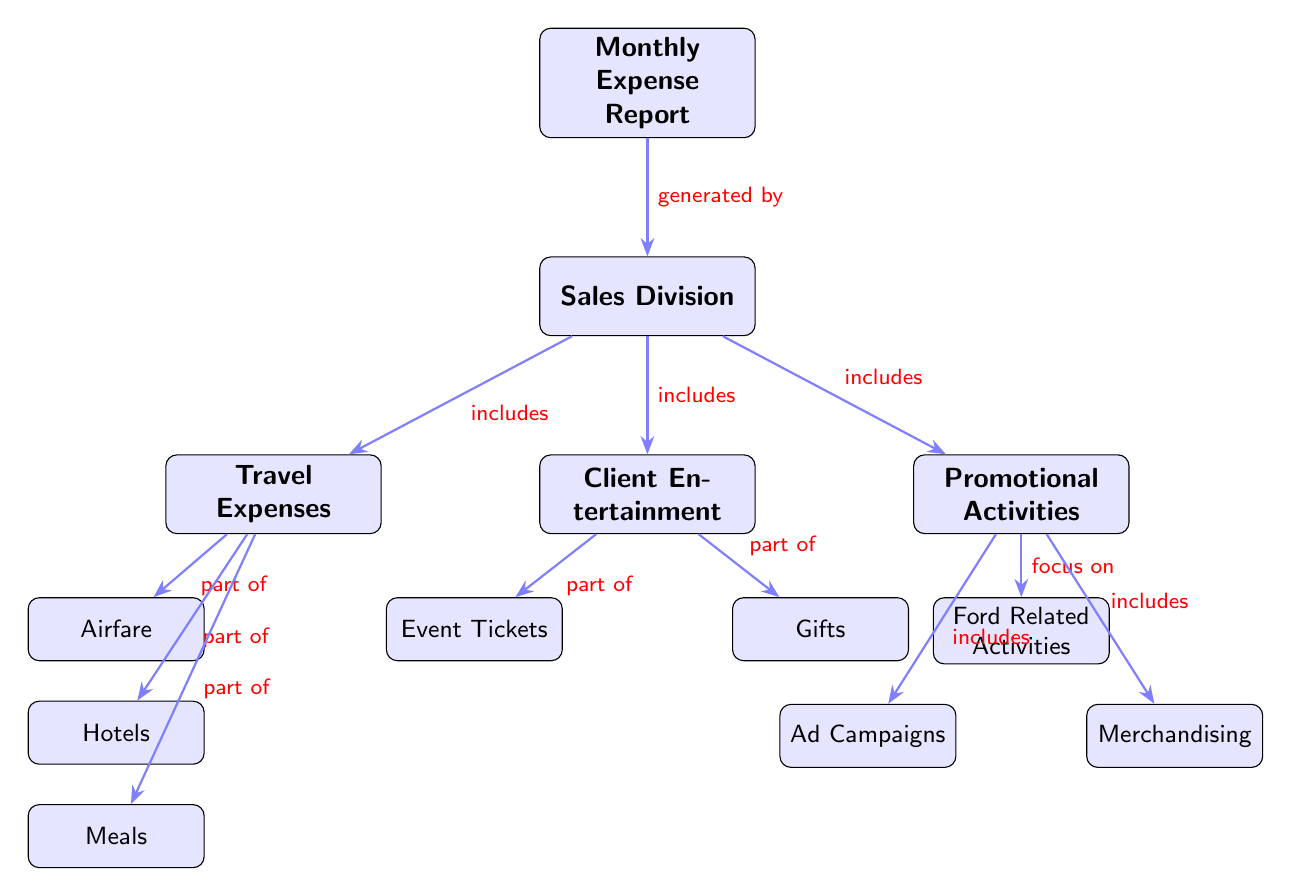What is the main focus of the diagram? The main node labeled "Monthly Expense Report" signifies the overall theme of the diagram, which is the tracking of expenses related to the sales division.
Answer: Monthly Expense Report How many categories fall under the Sales Division? The diagram displays three categories stemming from the node "Sales Division": Travel Expenses, Client Entertainment, and Promotional Activities.
Answer: Three What type of expense is associated with "Event Tickets"? "Event Tickets" is designated as a subcategory under the "Client Entertainment" node, indicating that it pertains to expenses related to entertaining clients.
Answer: Client Entertainment What are the three parts of Travel Expenses? The Travel Expenses category breaks down into three subcategories: Airfare, Hotels, and Meals, which represent various travel-related costs incurred by the sales division.
Answer: Airfare, Hotels, Meals Which node indicates expense focus on Ford-related activities? The node labeled "Ford Related Activities" under "Promotional Activities" clearly points towards expenses that are centered around initiatives related specifically to Ford.
Answer: Ford Related Activities How do Promotional Activities relate to Ad Campaigns? Promotional Activities includes Ad Campaigns as one of its subcategories, demonstrating that promotional expenses include costs associated with advertising campaigns for Ford.
Answer: Includes What additional expense category is connected to Ford Related Activities? In addition to Ad Campaigns, the Ford Related Activities node also includes Merchandising, showing a focus on promotional initiatives that incorporate selling Ford-branded products.
Answer: Merchandising What is the hierarchical relationship between Monthly Expense Report and Sales Division? The "Monthly Expense Report" is the parent node that encompasses the "Sales Division," meaning the report summarizes activities specifically for that division.
Answer: Generated by How many subcategories fall under Promotional Activities? Under the "Promotional Activities" node, there are three identifiable subcategories: Ford Related Activities, Ad Campaigns, and Merchandising, denoting different areas of expenditure.
Answer: Three 